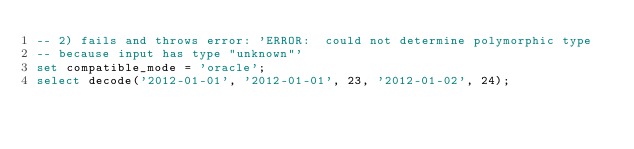Convert code to text. <code><loc_0><loc_0><loc_500><loc_500><_SQL_>-- 2) fails and throws error: 'ERROR:  could not determine polymorphic type 
-- because input has type "unknown"'
set compatible_mode = 'oracle';
select decode('2012-01-01', '2012-01-01', 23, '2012-01-02', 24);
</code> 